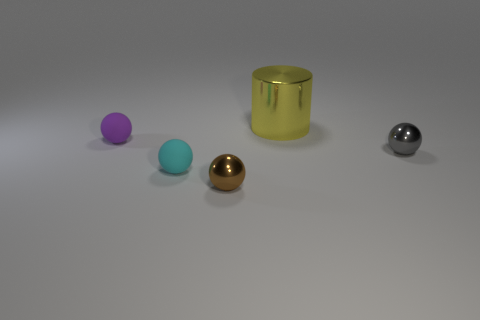There is a shiny object that is both in front of the purple matte thing and to the right of the brown sphere; what color is it?
Keep it short and to the point. Gray. Does the large yellow thing have the same material as the tiny brown object right of the cyan thing?
Your answer should be compact. Yes. What is the shape of the big yellow object that is made of the same material as the brown ball?
Give a very brief answer. Cylinder. There is a matte ball that is the same size as the cyan matte object; what color is it?
Offer a very short reply. Purple. Does the shiny ball that is to the left of the yellow metal cylinder have the same size as the large yellow shiny object?
Offer a terse response. No. How many tiny matte balls are there?
Ensure brevity in your answer.  2. What number of blocks are large metallic objects or tiny things?
Offer a terse response. 0. There is a small rubber sphere behind the tiny gray object; what number of tiny things are to the right of it?
Make the answer very short. 3. Is the brown sphere made of the same material as the yellow object?
Ensure brevity in your answer.  Yes. Are there any tiny objects made of the same material as the cylinder?
Offer a terse response. Yes. 